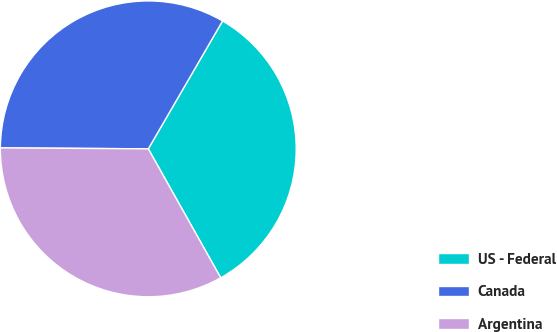Convert chart. <chart><loc_0><loc_0><loc_500><loc_500><pie_chart><fcel>US - Federal<fcel>Canada<fcel>Argentina<nl><fcel>33.48%<fcel>33.27%<fcel>33.25%<nl></chart> 